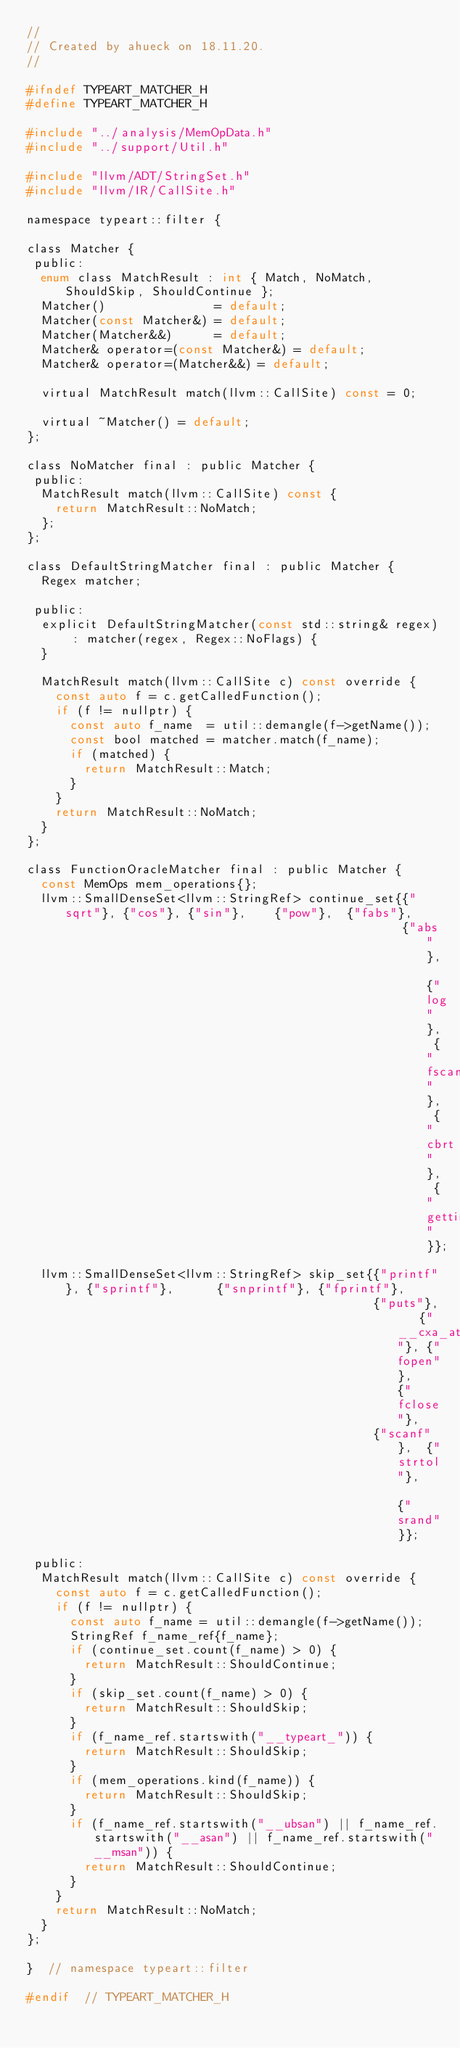Convert code to text. <code><loc_0><loc_0><loc_500><loc_500><_C_>//
// Created by ahueck on 18.11.20.
//

#ifndef TYPEART_MATCHER_H
#define TYPEART_MATCHER_H

#include "../analysis/MemOpData.h"
#include "../support/Util.h"

#include "llvm/ADT/StringSet.h"
#include "llvm/IR/CallSite.h"

namespace typeart::filter {

class Matcher {
 public:
  enum class MatchResult : int { Match, NoMatch, ShouldSkip, ShouldContinue };
  Matcher()               = default;
  Matcher(const Matcher&) = default;
  Matcher(Matcher&&)      = default;
  Matcher& operator=(const Matcher&) = default;
  Matcher& operator=(Matcher&&) = default;

  virtual MatchResult match(llvm::CallSite) const = 0;

  virtual ~Matcher() = default;
};

class NoMatcher final : public Matcher {
 public:
  MatchResult match(llvm::CallSite) const {
    return MatchResult::NoMatch;
  };
};

class DefaultStringMatcher final : public Matcher {
  Regex matcher;

 public:
  explicit DefaultStringMatcher(const std::string& regex) : matcher(regex, Regex::NoFlags) {
  }

  MatchResult match(llvm::CallSite c) const override {
    const auto f = c.getCalledFunction();
    if (f != nullptr) {
      const auto f_name  = util::demangle(f->getName());
      const bool matched = matcher.match(f_name);
      if (matched) {
        return MatchResult::Match;
      }
    }
    return MatchResult::NoMatch;
  }
};

class FunctionOracleMatcher final : public Matcher {
  const MemOps mem_operations{};
  llvm::SmallDenseSet<llvm::StringRef> continue_set{{"sqrt"}, {"cos"}, {"sin"},    {"pow"},  {"fabs"},
                                                    {"abs"},  {"log"}, {"fscanf"}, {"cbrt"}, {"gettimeofday"}};
  llvm::SmallDenseSet<llvm::StringRef> skip_set{{"printf"}, {"sprintf"},      {"snprintf"}, {"fprintf"},
                                                {"puts"},   {"__cxa_atexit"}, {"fopen"},    {"fclose"},
                                                {"scanf"},  {"strtol"},       {"srand"}};

 public:
  MatchResult match(llvm::CallSite c) const override {
    const auto f = c.getCalledFunction();
    if (f != nullptr) {
      const auto f_name = util::demangle(f->getName());
      StringRef f_name_ref{f_name};
      if (continue_set.count(f_name) > 0) {
        return MatchResult::ShouldContinue;
      }
      if (skip_set.count(f_name) > 0) {
        return MatchResult::ShouldSkip;
      }
      if (f_name_ref.startswith("__typeart_")) {
        return MatchResult::ShouldSkip;
      }
      if (mem_operations.kind(f_name)) {
        return MatchResult::ShouldSkip;
      }
      if (f_name_ref.startswith("__ubsan") || f_name_ref.startswith("__asan") || f_name_ref.startswith("__msan")) {
        return MatchResult::ShouldContinue;
      }
    }
    return MatchResult::NoMatch;
  }
};

}  // namespace typeart::filter

#endif  // TYPEART_MATCHER_H
</code> 